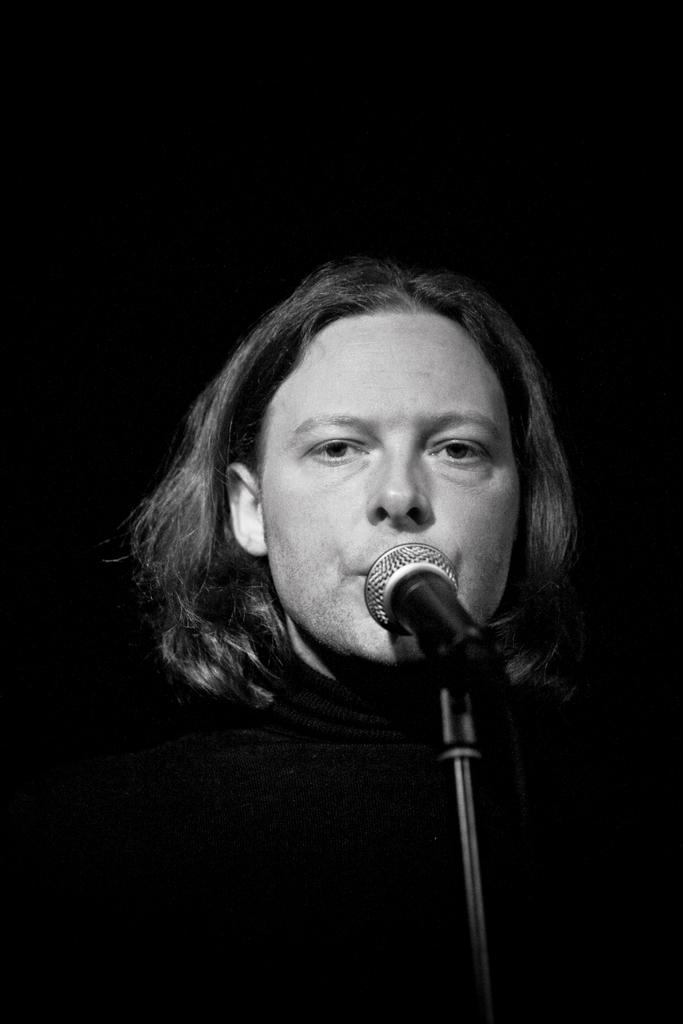Who or what is the main subject in the image? There is a person in the image. What is the person doing in the image? The person is in front of a microphone. Can you describe the background of the image? The background of the image is dark. What type of bucket can be seen in the image? There is no bucket present in the image. Is there a spring visible in the background of the image? There is no spring visible in the image; the background is dark. 